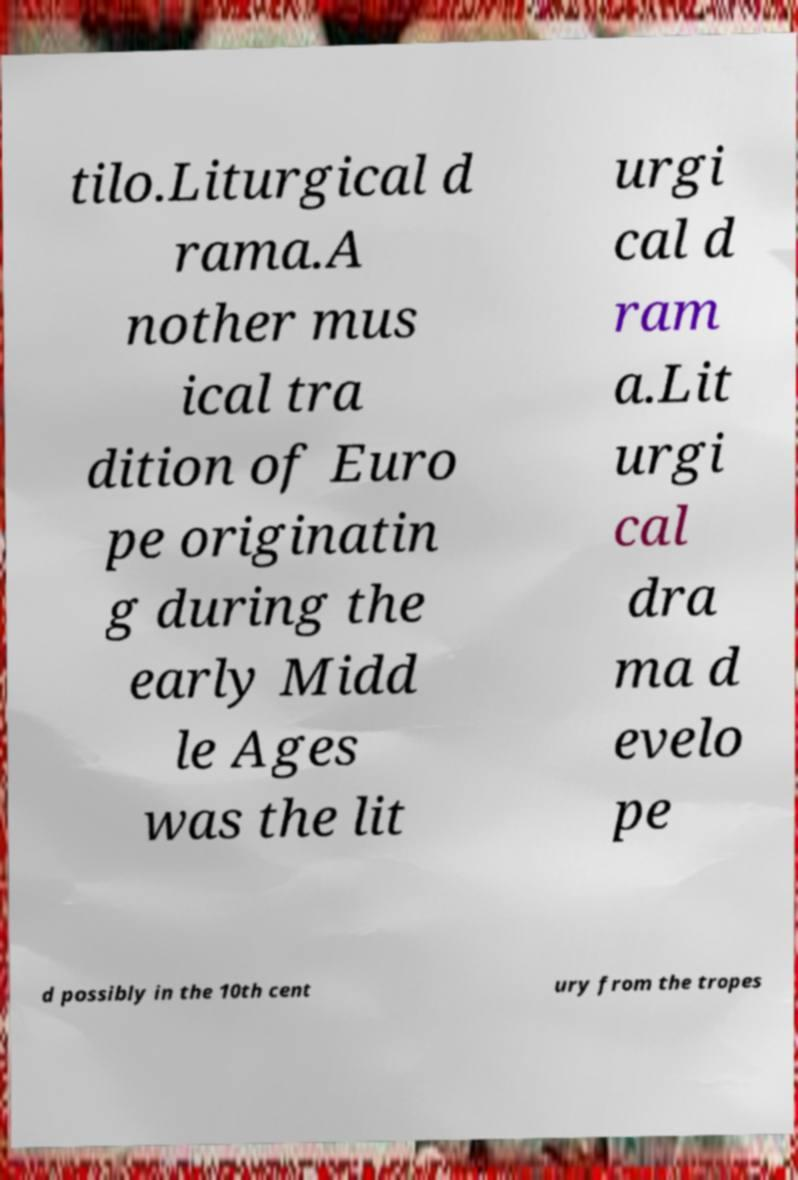There's text embedded in this image that I need extracted. Can you transcribe it verbatim? tilo.Liturgical d rama.A nother mus ical tra dition of Euro pe originatin g during the early Midd le Ages was the lit urgi cal d ram a.Lit urgi cal dra ma d evelo pe d possibly in the 10th cent ury from the tropes 